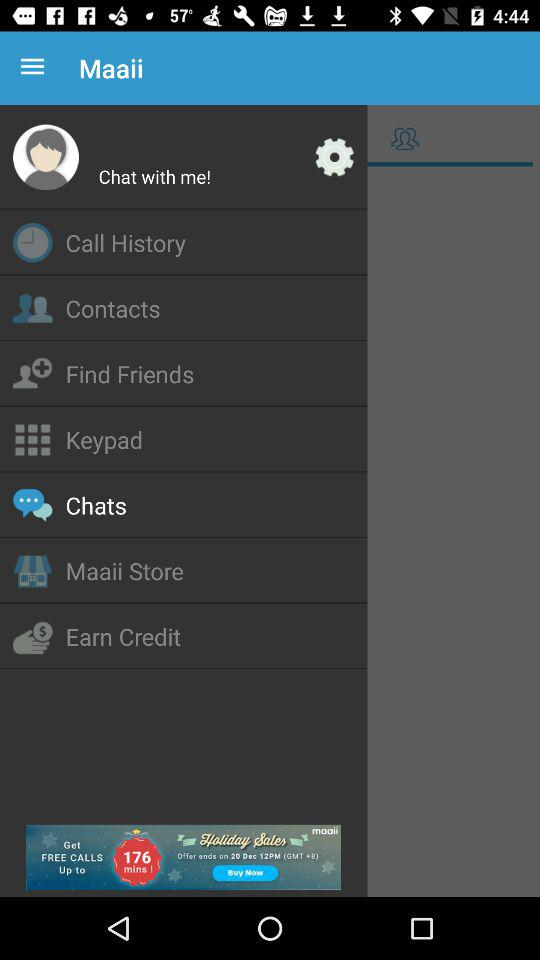What is the application name? The application name is "Maaii". 